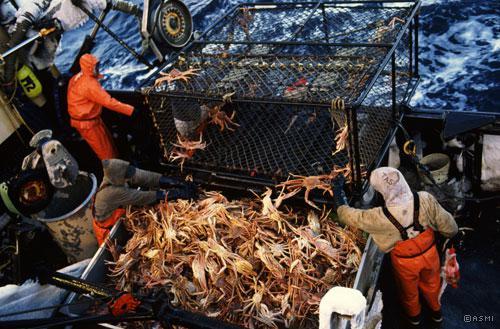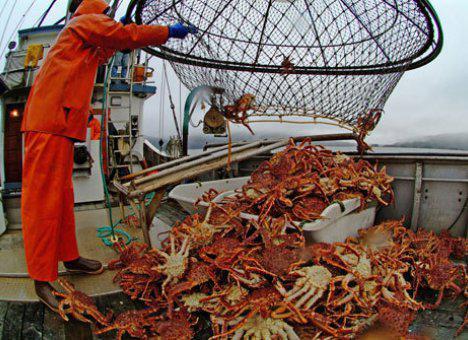The first image is the image on the left, the second image is the image on the right. Assess this claim about the two images: "In one image, a person wearing a front-brimmed hat and jacket is holding a single large crab with its legs outstretched.". Correct or not? Answer yes or no. No. The first image is the image on the left, the second image is the image on the right. For the images shown, is this caption "The right image features a person in a ball cap holding up a purple crab with the bare hand of the arm on the left." true? Answer yes or no. No. 